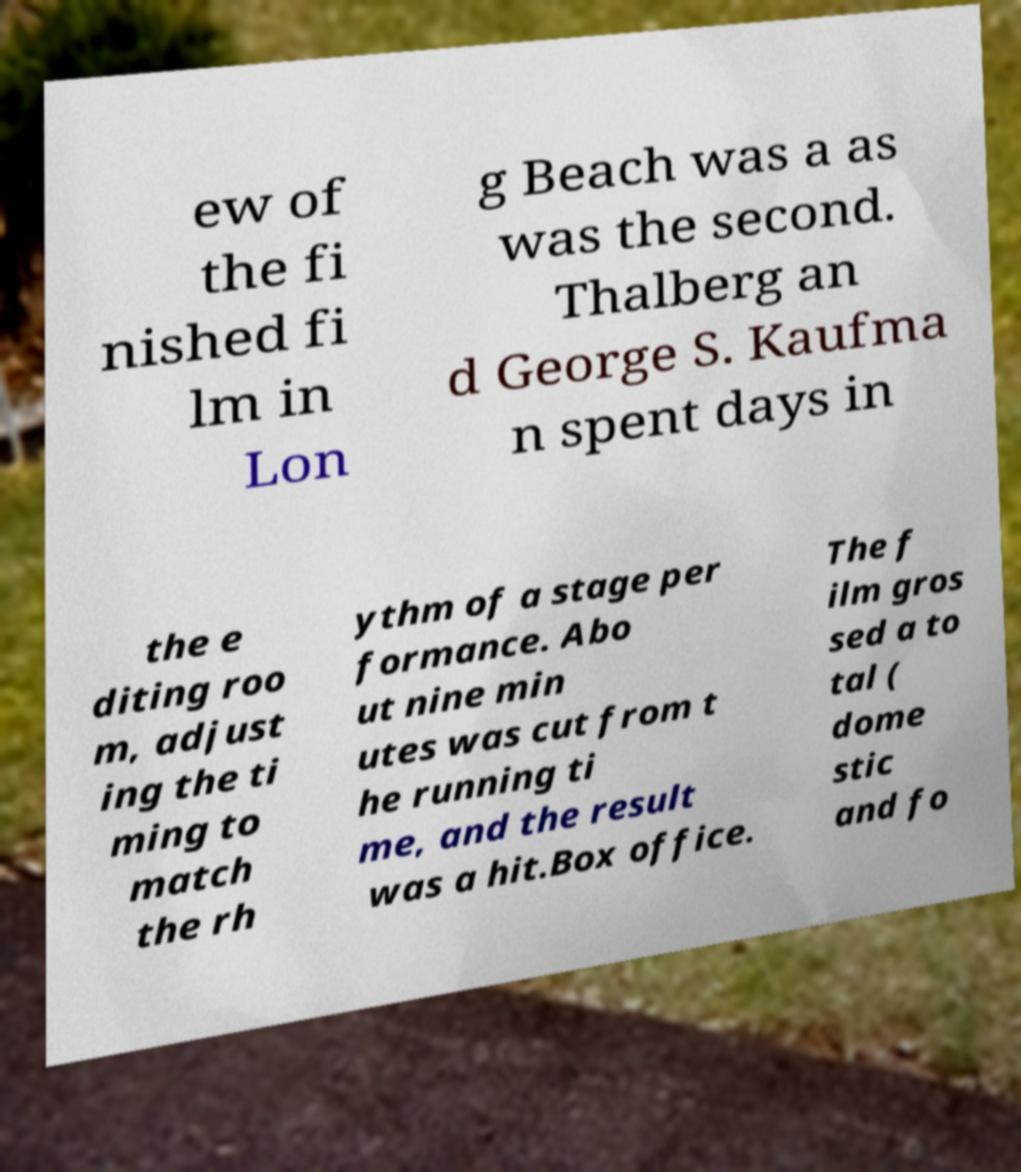Can you accurately transcribe the text from the provided image for me? ew of the fi nished fi lm in Lon g Beach was a as was the second. Thalberg an d George S. Kaufma n spent days in the e diting roo m, adjust ing the ti ming to match the rh ythm of a stage per formance. Abo ut nine min utes was cut from t he running ti me, and the result was a hit.Box office. The f ilm gros sed a to tal ( dome stic and fo 